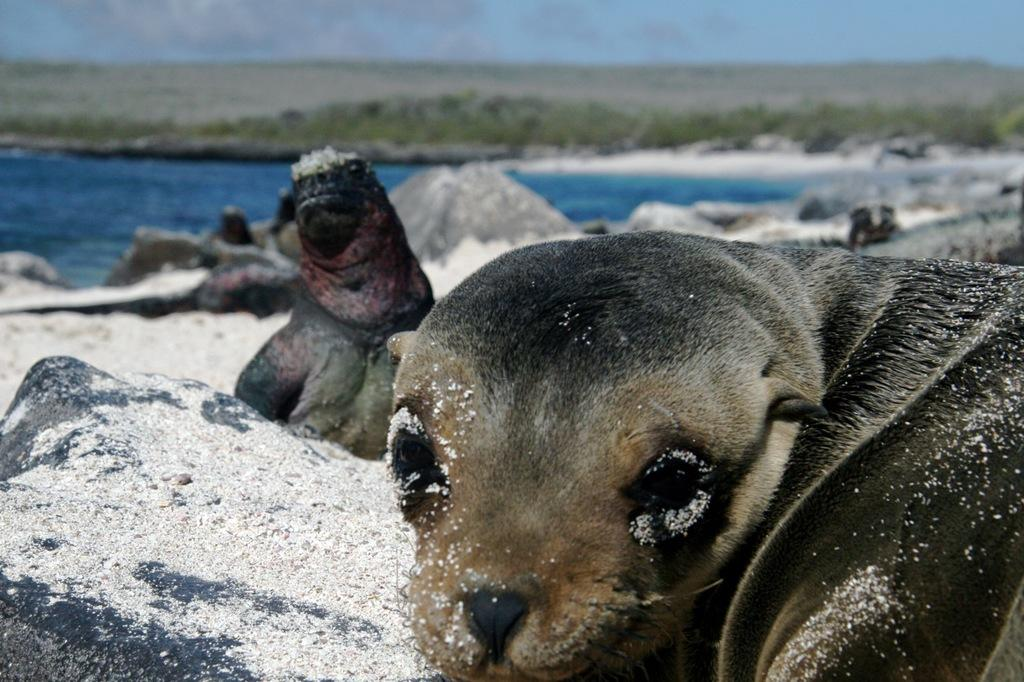What is the main subject of the image? There are animals sitting on the ground in the image. What can be seen in the background of the image? Water, rocks, and the sky are visible in the background of the image. How is the background of the image depicted? The background of the image is blurred. What type of zephyr can be seen blowing through the church in the image? There is no church or zephyr present in the image. 